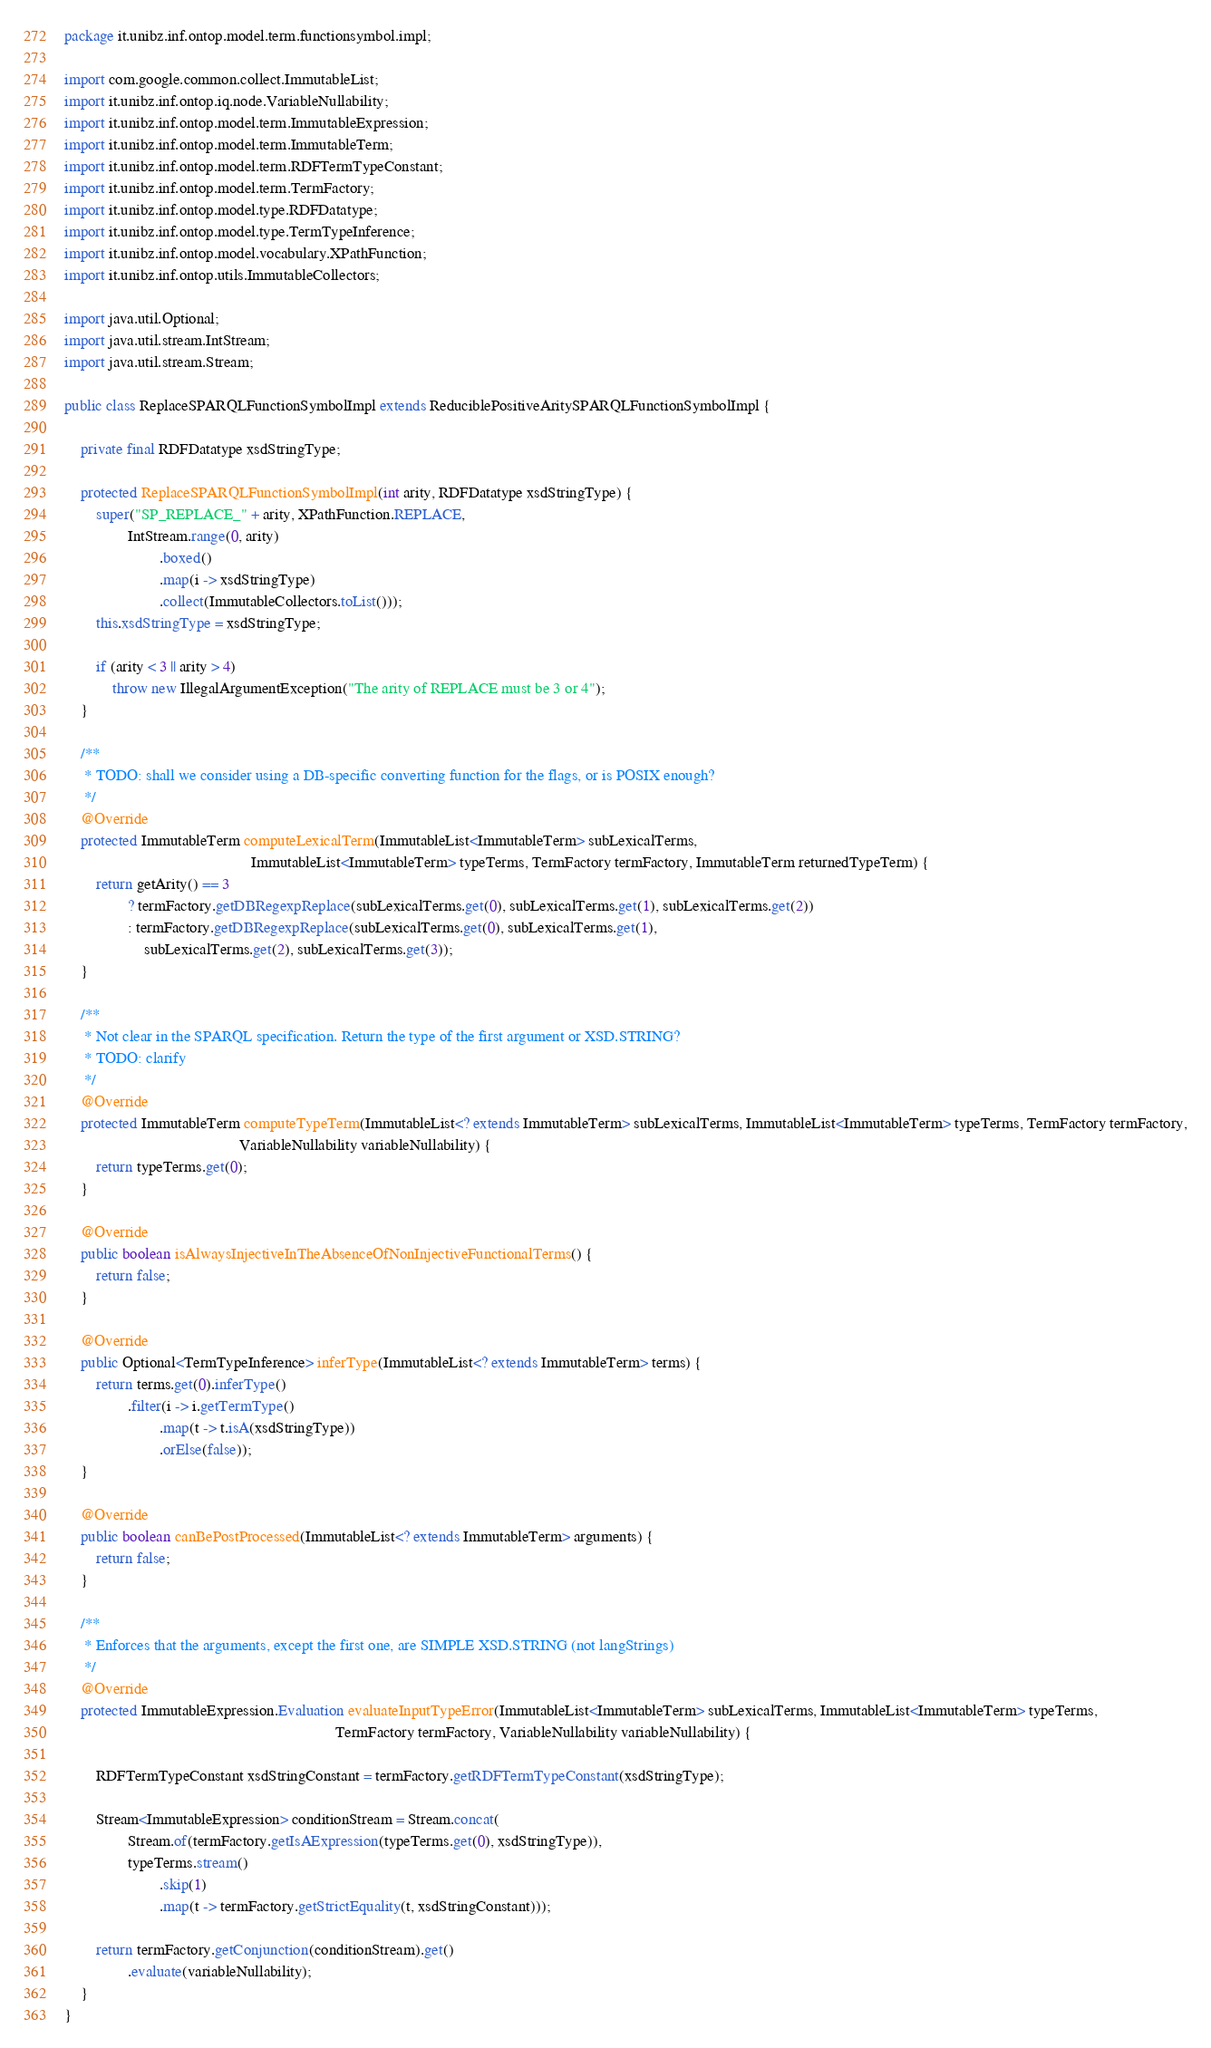<code> <loc_0><loc_0><loc_500><loc_500><_Java_>package it.unibz.inf.ontop.model.term.functionsymbol.impl;

import com.google.common.collect.ImmutableList;
import it.unibz.inf.ontop.iq.node.VariableNullability;
import it.unibz.inf.ontop.model.term.ImmutableExpression;
import it.unibz.inf.ontop.model.term.ImmutableTerm;
import it.unibz.inf.ontop.model.term.RDFTermTypeConstant;
import it.unibz.inf.ontop.model.term.TermFactory;
import it.unibz.inf.ontop.model.type.RDFDatatype;
import it.unibz.inf.ontop.model.type.TermTypeInference;
import it.unibz.inf.ontop.model.vocabulary.XPathFunction;
import it.unibz.inf.ontop.utils.ImmutableCollectors;

import java.util.Optional;
import java.util.stream.IntStream;
import java.util.stream.Stream;

public class ReplaceSPARQLFunctionSymbolImpl extends ReduciblePositiveAritySPARQLFunctionSymbolImpl {

    private final RDFDatatype xsdStringType;

    protected ReplaceSPARQLFunctionSymbolImpl(int arity, RDFDatatype xsdStringType) {
        super("SP_REPLACE_" + arity, XPathFunction.REPLACE,
                IntStream.range(0, arity)
                        .boxed()
                        .map(i -> xsdStringType)
                        .collect(ImmutableCollectors.toList()));
        this.xsdStringType = xsdStringType;

        if (arity < 3 || arity > 4)
            throw new IllegalArgumentException("The arity of REPLACE must be 3 or 4");
    }

    /**
     * TODO: shall we consider using a DB-specific converting function for the flags, or is POSIX enough?
     */
    @Override
    protected ImmutableTerm computeLexicalTerm(ImmutableList<ImmutableTerm> subLexicalTerms,
                                               ImmutableList<ImmutableTerm> typeTerms, TermFactory termFactory, ImmutableTerm returnedTypeTerm) {
        return getArity() == 3
                ? termFactory.getDBRegexpReplace(subLexicalTerms.get(0), subLexicalTerms.get(1), subLexicalTerms.get(2))
                : termFactory.getDBRegexpReplace(subLexicalTerms.get(0), subLexicalTerms.get(1),
                    subLexicalTerms.get(2), subLexicalTerms.get(3));
    }

    /**
     * Not clear in the SPARQL specification. Return the type of the first argument or XSD.STRING?
     * TODO: clarify
     */
    @Override
    protected ImmutableTerm computeTypeTerm(ImmutableList<? extends ImmutableTerm> subLexicalTerms, ImmutableList<ImmutableTerm> typeTerms, TermFactory termFactory,
                                            VariableNullability variableNullability) {
        return typeTerms.get(0);
    }

    @Override
    public boolean isAlwaysInjectiveInTheAbsenceOfNonInjectiveFunctionalTerms() {
        return false;
    }

    @Override
    public Optional<TermTypeInference> inferType(ImmutableList<? extends ImmutableTerm> terms) {
        return terms.get(0).inferType()
                .filter(i -> i.getTermType()
                        .map(t -> t.isA(xsdStringType))
                        .orElse(false));
    }

    @Override
    public boolean canBePostProcessed(ImmutableList<? extends ImmutableTerm> arguments) {
        return false;
    }

    /**
     * Enforces that the arguments, except the first one, are SIMPLE XSD.STRING (not langStrings)
     */
    @Override
    protected ImmutableExpression.Evaluation evaluateInputTypeError(ImmutableList<ImmutableTerm> subLexicalTerms, ImmutableList<ImmutableTerm> typeTerms,
                                                                    TermFactory termFactory, VariableNullability variableNullability) {

        RDFTermTypeConstant xsdStringConstant = termFactory.getRDFTermTypeConstant(xsdStringType);

        Stream<ImmutableExpression> conditionStream = Stream.concat(
                Stream.of(termFactory.getIsAExpression(typeTerms.get(0), xsdStringType)),
                typeTerms.stream()
                        .skip(1)
                        .map(t -> termFactory.getStrictEquality(t, xsdStringConstant)));

        return termFactory.getConjunction(conditionStream).get()
                .evaluate(variableNullability);
    }
}
</code> 